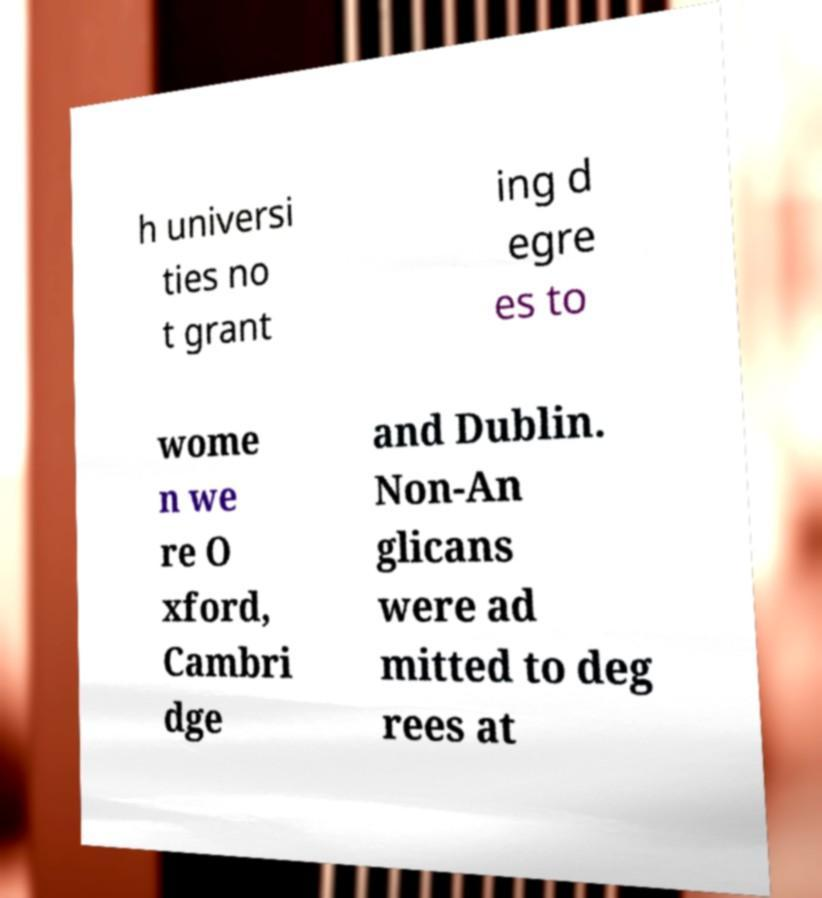Can you accurately transcribe the text from the provided image for me? h universi ties no t grant ing d egre es to wome n we re O xford, Cambri dge and Dublin. Non-An glicans were ad mitted to deg rees at 